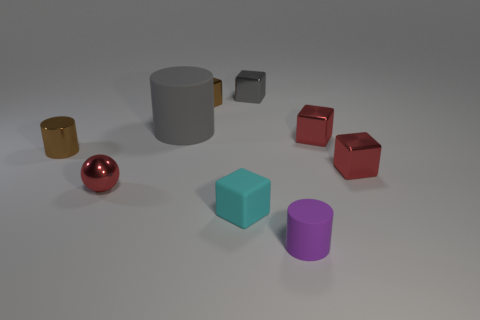Does the tiny purple thing have the same material as the small red block that is behind the tiny metal cylinder?
Your answer should be very brief. No. There is a metal ball that is the same size as the cyan matte object; what color is it?
Provide a short and direct response. Red. What size is the rubber cylinder that is behind the small cylinder in front of the cyan matte thing?
Provide a short and direct response. Large. There is a small sphere; does it have the same color as the small cylinder right of the tiny gray cube?
Provide a succinct answer. No. Is the number of cubes that are on the left side of the brown block less than the number of purple matte cylinders?
Provide a short and direct response. Yes. How many other things are the same size as the gray block?
Your response must be concise. 7. Do the tiny brown metallic object on the left side of the tiny red shiny ball and the gray metallic object have the same shape?
Offer a very short reply. No. Is the number of metallic things that are behind the big cylinder greater than the number of big purple metal objects?
Provide a short and direct response. Yes. What material is the small thing that is both behind the ball and to the left of the big gray object?
Provide a short and direct response. Metal. Are there any other things that have the same shape as the tiny gray thing?
Offer a very short reply. Yes. 